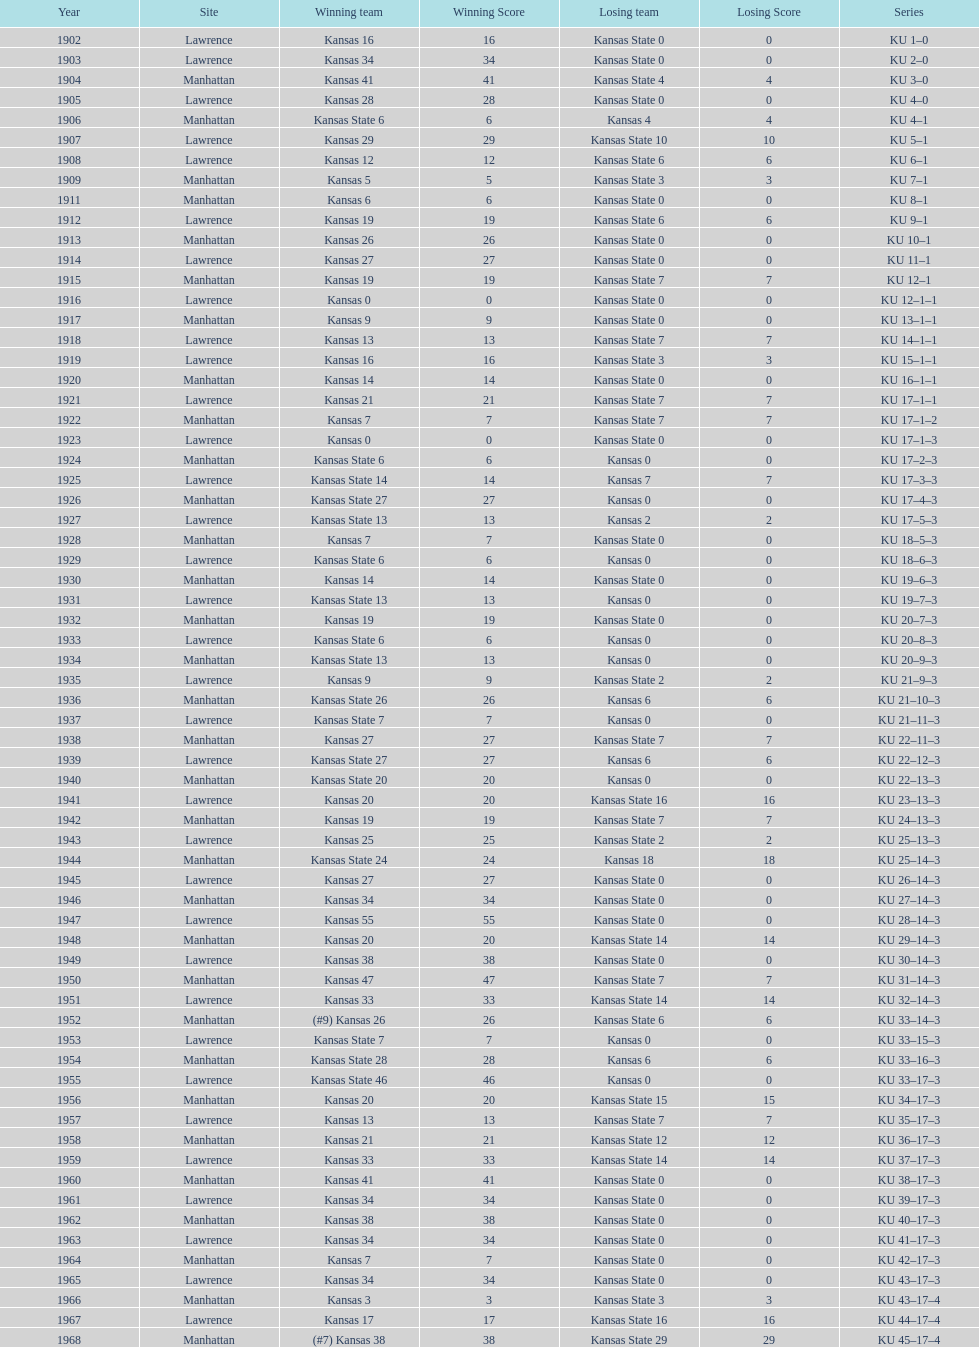How many times did kansas beat kansas state before 1910? 7. 